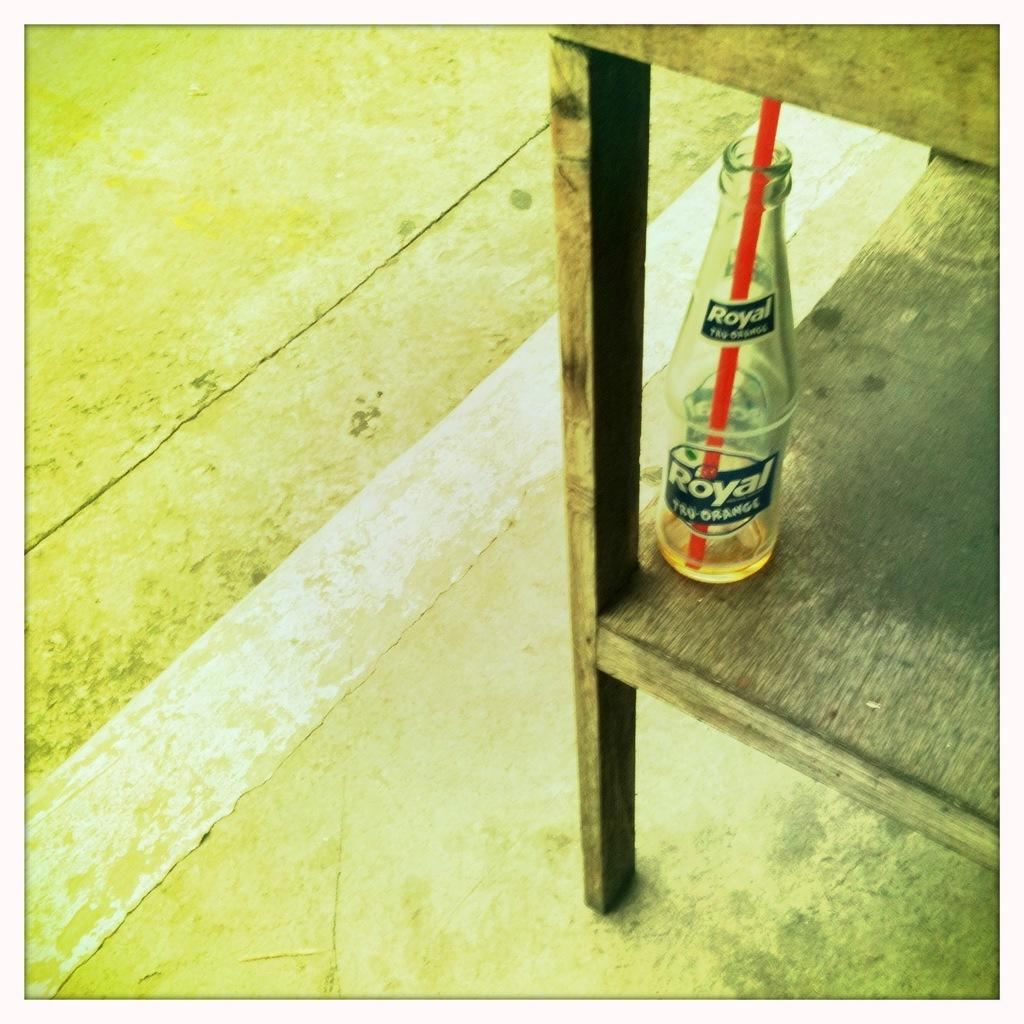<image>
Summarize the visual content of the image. A bottle of Royal Tru-Orange soda with a red straw in it 